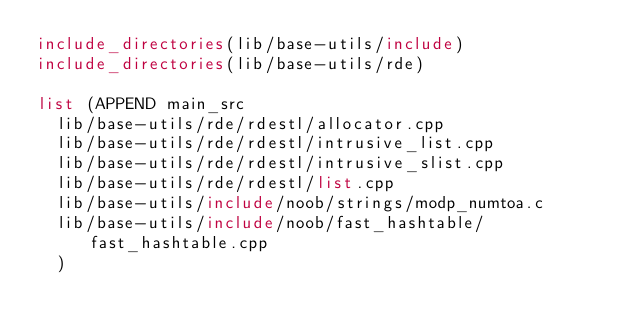Convert code to text. <code><loc_0><loc_0><loc_500><loc_500><_CMake_>include_directories(lib/base-utils/include)
include_directories(lib/base-utils/rde)

list (APPEND main_src
	lib/base-utils/rde/rdestl/allocator.cpp
	lib/base-utils/rde/rdestl/intrusive_list.cpp
	lib/base-utils/rde/rdestl/intrusive_slist.cpp
	lib/base-utils/rde/rdestl/list.cpp
	lib/base-utils/include/noob/strings/modp_numtoa.c
	lib/base-utils/include/noob/fast_hashtable/fast_hashtable.cpp
	)
</code> 